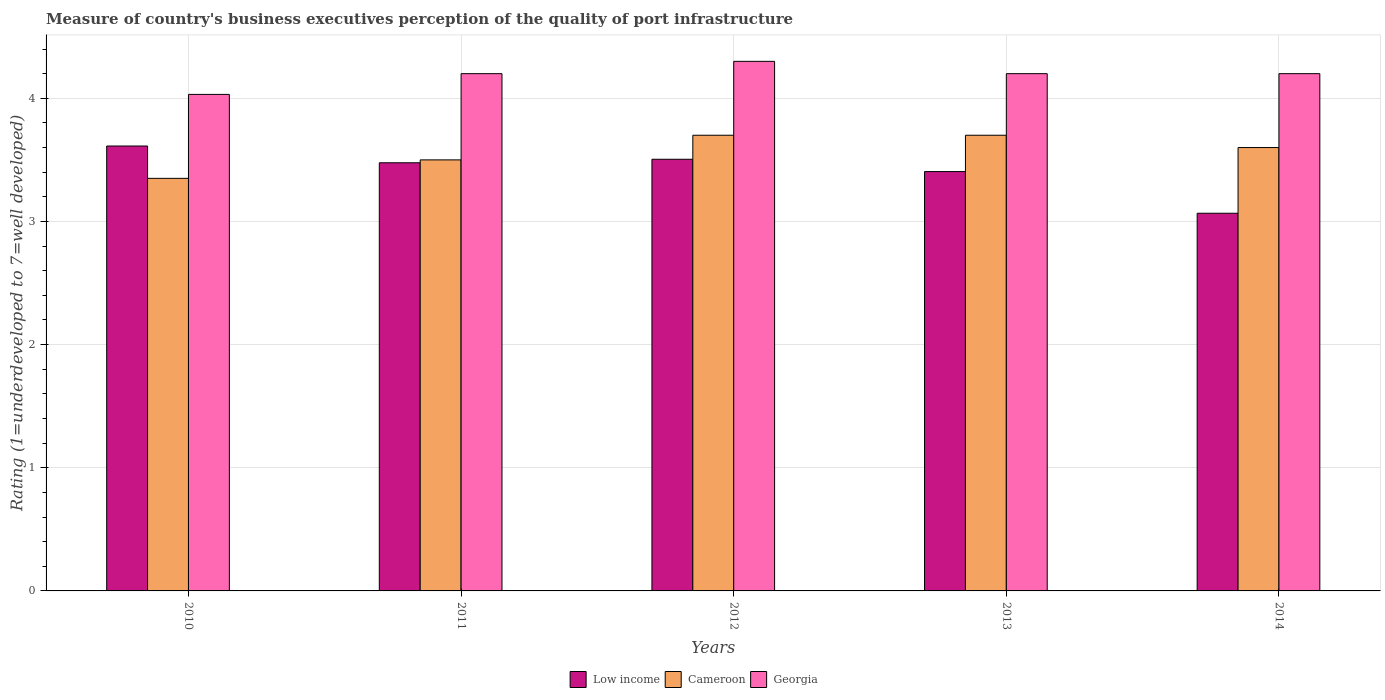Are the number of bars per tick equal to the number of legend labels?
Offer a very short reply. Yes. Are the number of bars on each tick of the X-axis equal?
Offer a very short reply. Yes. How many bars are there on the 2nd tick from the left?
Give a very brief answer. 3. In how many cases, is the number of bars for a given year not equal to the number of legend labels?
Your answer should be compact. 0. Across all years, what is the maximum ratings of the quality of port infrastructure in Low income?
Ensure brevity in your answer.  3.61. Across all years, what is the minimum ratings of the quality of port infrastructure in Cameroon?
Provide a short and direct response. 3.35. What is the total ratings of the quality of port infrastructure in Cameroon in the graph?
Give a very brief answer. 17.85. What is the difference between the ratings of the quality of port infrastructure in Cameroon in 2010 and that in 2013?
Ensure brevity in your answer.  -0.35. What is the difference between the ratings of the quality of port infrastructure in Georgia in 2014 and the ratings of the quality of port infrastructure in Low income in 2012?
Your answer should be compact. 0.7. What is the average ratings of the quality of port infrastructure in Georgia per year?
Give a very brief answer. 4.19. In the year 2014, what is the difference between the ratings of the quality of port infrastructure in Low income and ratings of the quality of port infrastructure in Cameroon?
Your answer should be compact. -0.53. In how many years, is the ratings of the quality of port infrastructure in Low income greater than 4.2?
Ensure brevity in your answer.  0. Is the difference between the ratings of the quality of port infrastructure in Low income in 2010 and 2013 greater than the difference between the ratings of the quality of port infrastructure in Cameroon in 2010 and 2013?
Give a very brief answer. Yes. What is the difference between the highest and the second highest ratings of the quality of port infrastructure in Low income?
Provide a short and direct response. 0.11. What is the difference between the highest and the lowest ratings of the quality of port infrastructure in Low income?
Provide a succinct answer. 0.55. Is the sum of the ratings of the quality of port infrastructure in Georgia in 2011 and 2014 greater than the maximum ratings of the quality of port infrastructure in Cameroon across all years?
Offer a very short reply. Yes. What does the 2nd bar from the left in 2011 represents?
Your answer should be compact. Cameroon. What does the 2nd bar from the right in 2013 represents?
Give a very brief answer. Cameroon. How many years are there in the graph?
Keep it short and to the point. 5. What is the difference between two consecutive major ticks on the Y-axis?
Provide a succinct answer. 1. Where does the legend appear in the graph?
Your answer should be compact. Bottom center. How many legend labels are there?
Keep it short and to the point. 3. How are the legend labels stacked?
Keep it short and to the point. Horizontal. What is the title of the graph?
Your response must be concise. Measure of country's business executives perception of the quality of port infrastructure. What is the label or title of the Y-axis?
Provide a short and direct response. Rating (1=underdeveloped to 7=well developed). What is the Rating (1=underdeveloped to 7=well developed) of Low income in 2010?
Offer a very short reply. 3.61. What is the Rating (1=underdeveloped to 7=well developed) in Cameroon in 2010?
Give a very brief answer. 3.35. What is the Rating (1=underdeveloped to 7=well developed) of Georgia in 2010?
Keep it short and to the point. 4.03. What is the Rating (1=underdeveloped to 7=well developed) in Low income in 2011?
Make the answer very short. 3.48. What is the Rating (1=underdeveloped to 7=well developed) in Cameroon in 2011?
Offer a terse response. 3.5. What is the Rating (1=underdeveloped to 7=well developed) of Low income in 2012?
Your answer should be very brief. 3.5. What is the Rating (1=underdeveloped to 7=well developed) in Low income in 2013?
Your response must be concise. 3.4. What is the Rating (1=underdeveloped to 7=well developed) of Cameroon in 2013?
Ensure brevity in your answer.  3.7. What is the Rating (1=underdeveloped to 7=well developed) of Georgia in 2013?
Ensure brevity in your answer.  4.2. What is the Rating (1=underdeveloped to 7=well developed) in Low income in 2014?
Your answer should be compact. 3.07. Across all years, what is the maximum Rating (1=underdeveloped to 7=well developed) in Low income?
Your response must be concise. 3.61. Across all years, what is the maximum Rating (1=underdeveloped to 7=well developed) in Georgia?
Provide a succinct answer. 4.3. Across all years, what is the minimum Rating (1=underdeveloped to 7=well developed) in Low income?
Keep it short and to the point. 3.07. Across all years, what is the minimum Rating (1=underdeveloped to 7=well developed) in Cameroon?
Provide a short and direct response. 3.35. Across all years, what is the minimum Rating (1=underdeveloped to 7=well developed) in Georgia?
Your response must be concise. 4.03. What is the total Rating (1=underdeveloped to 7=well developed) in Low income in the graph?
Give a very brief answer. 17.07. What is the total Rating (1=underdeveloped to 7=well developed) in Cameroon in the graph?
Your answer should be very brief. 17.85. What is the total Rating (1=underdeveloped to 7=well developed) of Georgia in the graph?
Your answer should be very brief. 20.93. What is the difference between the Rating (1=underdeveloped to 7=well developed) of Low income in 2010 and that in 2011?
Your answer should be compact. 0.14. What is the difference between the Rating (1=underdeveloped to 7=well developed) of Cameroon in 2010 and that in 2011?
Ensure brevity in your answer.  -0.15. What is the difference between the Rating (1=underdeveloped to 7=well developed) of Georgia in 2010 and that in 2011?
Your answer should be very brief. -0.17. What is the difference between the Rating (1=underdeveloped to 7=well developed) of Low income in 2010 and that in 2012?
Make the answer very short. 0.11. What is the difference between the Rating (1=underdeveloped to 7=well developed) of Cameroon in 2010 and that in 2012?
Your answer should be very brief. -0.35. What is the difference between the Rating (1=underdeveloped to 7=well developed) in Georgia in 2010 and that in 2012?
Your answer should be very brief. -0.27. What is the difference between the Rating (1=underdeveloped to 7=well developed) in Low income in 2010 and that in 2013?
Provide a succinct answer. 0.21. What is the difference between the Rating (1=underdeveloped to 7=well developed) in Cameroon in 2010 and that in 2013?
Your response must be concise. -0.35. What is the difference between the Rating (1=underdeveloped to 7=well developed) in Georgia in 2010 and that in 2013?
Keep it short and to the point. -0.17. What is the difference between the Rating (1=underdeveloped to 7=well developed) of Low income in 2010 and that in 2014?
Ensure brevity in your answer.  0.55. What is the difference between the Rating (1=underdeveloped to 7=well developed) of Cameroon in 2010 and that in 2014?
Your answer should be compact. -0.25. What is the difference between the Rating (1=underdeveloped to 7=well developed) in Georgia in 2010 and that in 2014?
Ensure brevity in your answer.  -0.17. What is the difference between the Rating (1=underdeveloped to 7=well developed) of Low income in 2011 and that in 2012?
Keep it short and to the point. -0.03. What is the difference between the Rating (1=underdeveloped to 7=well developed) in Cameroon in 2011 and that in 2012?
Your answer should be compact. -0.2. What is the difference between the Rating (1=underdeveloped to 7=well developed) in Georgia in 2011 and that in 2012?
Provide a succinct answer. -0.1. What is the difference between the Rating (1=underdeveloped to 7=well developed) in Low income in 2011 and that in 2013?
Your answer should be compact. 0.07. What is the difference between the Rating (1=underdeveloped to 7=well developed) in Georgia in 2011 and that in 2013?
Keep it short and to the point. 0. What is the difference between the Rating (1=underdeveloped to 7=well developed) of Low income in 2011 and that in 2014?
Your answer should be very brief. 0.41. What is the difference between the Rating (1=underdeveloped to 7=well developed) of Georgia in 2011 and that in 2014?
Your response must be concise. 0. What is the difference between the Rating (1=underdeveloped to 7=well developed) of Low income in 2012 and that in 2013?
Your answer should be very brief. 0.1. What is the difference between the Rating (1=underdeveloped to 7=well developed) of Cameroon in 2012 and that in 2013?
Your answer should be very brief. 0. What is the difference between the Rating (1=underdeveloped to 7=well developed) in Georgia in 2012 and that in 2013?
Offer a terse response. 0.1. What is the difference between the Rating (1=underdeveloped to 7=well developed) in Low income in 2012 and that in 2014?
Make the answer very short. 0.44. What is the difference between the Rating (1=underdeveloped to 7=well developed) of Georgia in 2012 and that in 2014?
Keep it short and to the point. 0.1. What is the difference between the Rating (1=underdeveloped to 7=well developed) in Low income in 2013 and that in 2014?
Ensure brevity in your answer.  0.34. What is the difference between the Rating (1=underdeveloped to 7=well developed) in Cameroon in 2013 and that in 2014?
Your response must be concise. 0.1. What is the difference between the Rating (1=underdeveloped to 7=well developed) of Low income in 2010 and the Rating (1=underdeveloped to 7=well developed) of Cameroon in 2011?
Offer a terse response. 0.11. What is the difference between the Rating (1=underdeveloped to 7=well developed) of Low income in 2010 and the Rating (1=underdeveloped to 7=well developed) of Georgia in 2011?
Keep it short and to the point. -0.59. What is the difference between the Rating (1=underdeveloped to 7=well developed) of Cameroon in 2010 and the Rating (1=underdeveloped to 7=well developed) of Georgia in 2011?
Your answer should be compact. -0.85. What is the difference between the Rating (1=underdeveloped to 7=well developed) in Low income in 2010 and the Rating (1=underdeveloped to 7=well developed) in Cameroon in 2012?
Offer a terse response. -0.09. What is the difference between the Rating (1=underdeveloped to 7=well developed) in Low income in 2010 and the Rating (1=underdeveloped to 7=well developed) in Georgia in 2012?
Your response must be concise. -0.69. What is the difference between the Rating (1=underdeveloped to 7=well developed) of Cameroon in 2010 and the Rating (1=underdeveloped to 7=well developed) of Georgia in 2012?
Make the answer very short. -0.95. What is the difference between the Rating (1=underdeveloped to 7=well developed) in Low income in 2010 and the Rating (1=underdeveloped to 7=well developed) in Cameroon in 2013?
Give a very brief answer. -0.09. What is the difference between the Rating (1=underdeveloped to 7=well developed) in Low income in 2010 and the Rating (1=underdeveloped to 7=well developed) in Georgia in 2013?
Offer a terse response. -0.59. What is the difference between the Rating (1=underdeveloped to 7=well developed) in Cameroon in 2010 and the Rating (1=underdeveloped to 7=well developed) in Georgia in 2013?
Your response must be concise. -0.85. What is the difference between the Rating (1=underdeveloped to 7=well developed) of Low income in 2010 and the Rating (1=underdeveloped to 7=well developed) of Cameroon in 2014?
Provide a short and direct response. 0.01. What is the difference between the Rating (1=underdeveloped to 7=well developed) of Low income in 2010 and the Rating (1=underdeveloped to 7=well developed) of Georgia in 2014?
Your answer should be compact. -0.59. What is the difference between the Rating (1=underdeveloped to 7=well developed) of Cameroon in 2010 and the Rating (1=underdeveloped to 7=well developed) of Georgia in 2014?
Your answer should be very brief. -0.85. What is the difference between the Rating (1=underdeveloped to 7=well developed) of Low income in 2011 and the Rating (1=underdeveloped to 7=well developed) of Cameroon in 2012?
Your response must be concise. -0.22. What is the difference between the Rating (1=underdeveloped to 7=well developed) of Low income in 2011 and the Rating (1=underdeveloped to 7=well developed) of Georgia in 2012?
Provide a succinct answer. -0.82. What is the difference between the Rating (1=underdeveloped to 7=well developed) in Cameroon in 2011 and the Rating (1=underdeveloped to 7=well developed) in Georgia in 2012?
Give a very brief answer. -0.8. What is the difference between the Rating (1=underdeveloped to 7=well developed) in Low income in 2011 and the Rating (1=underdeveloped to 7=well developed) in Cameroon in 2013?
Offer a terse response. -0.22. What is the difference between the Rating (1=underdeveloped to 7=well developed) in Low income in 2011 and the Rating (1=underdeveloped to 7=well developed) in Georgia in 2013?
Ensure brevity in your answer.  -0.72. What is the difference between the Rating (1=underdeveloped to 7=well developed) in Cameroon in 2011 and the Rating (1=underdeveloped to 7=well developed) in Georgia in 2013?
Keep it short and to the point. -0.7. What is the difference between the Rating (1=underdeveloped to 7=well developed) of Low income in 2011 and the Rating (1=underdeveloped to 7=well developed) of Cameroon in 2014?
Offer a very short reply. -0.12. What is the difference between the Rating (1=underdeveloped to 7=well developed) of Low income in 2011 and the Rating (1=underdeveloped to 7=well developed) of Georgia in 2014?
Give a very brief answer. -0.72. What is the difference between the Rating (1=underdeveloped to 7=well developed) of Cameroon in 2011 and the Rating (1=underdeveloped to 7=well developed) of Georgia in 2014?
Offer a very short reply. -0.7. What is the difference between the Rating (1=underdeveloped to 7=well developed) in Low income in 2012 and the Rating (1=underdeveloped to 7=well developed) in Cameroon in 2013?
Offer a very short reply. -0.2. What is the difference between the Rating (1=underdeveloped to 7=well developed) of Low income in 2012 and the Rating (1=underdeveloped to 7=well developed) of Georgia in 2013?
Make the answer very short. -0.69. What is the difference between the Rating (1=underdeveloped to 7=well developed) in Cameroon in 2012 and the Rating (1=underdeveloped to 7=well developed) in Georgia in 2013?
Offer a terse response. -0.5. What is the difference between the Rating (1=underdeveloped to 7=well developed) of Low income in 2012 and the Rating (1=underdeveloped to 7=well developed) of Cameroon in 2014?
Your response must be concise. -0.1. What is the difference between the Rating (1=underdeveloped to 7=well developed) in Low income in 2012 and the Rating (1=underdeveloped to 7=well developed) in Georgia in 2014?
Your response must be concise. -0.69. What is the difference between the Rating (1=underdeveloped to 7=well developed) in Low income in 2013 and the Rating (1=underdeveloped to 7=well developed) in Cameroon in 2014?
Your answer should be compact. -0.2. What is the difference between the Rating (1=underdeveloped to 7=well developed) in Low income in 2013 and the Rating (1=underdeveloped to 7=well developed) in Georgia in 2014?
Keep it short and to the point. -0.8. What is the average Rating (1=underdeveloped to 7=well developed) of Low income per year?
Your answer should be compact. 3.41. What is the average Rating (1=underdeveloped to 7=well developed) of Cameroon per year?
Your answer should be compact. 3.57. What is the average Rating (1=underdeveloped to 7=well developed) of Georgia per year?
Offer a very short reply. 4.19. In the year 2010, what is the difference between the Rating (1=underdeveloped to 7=well developed) of Low income and Rating (1=underdeveloped to 7=well developed) of Cameroon?
Provide a succinct answer. 0.26. In the year 2010, what is the difference between the Rating (1=underdeveloped to 7=well developed) of Low income and Rating (1=underdeveloped to 7=well developed) of Georgia?
Give a very brief answer. -0.42. In the year 2010, what is the difference between the Rating (1=underdeveloped to 7=well developed) in Cameroon and Rating (1=underdeveloped to 7=well developed) in Georgia?
Provide a succinct answer. -0.68. In the year 2011, what is the difference between the Rating (1=underdeveloped to 7=well developed) of Low income and Rating (1=underdeveloped to 7=well developed) of Cameroon?
Ensure brevity in your answer.  -0.02. In the year 2011, what is the difference between the Rating (1=underdeveloped to 7=well developed) of Low income and Rating (1=underdeveloped to 7=well developed) of Georgia?
Provide a short and direct response. -0.72. In the year 2011, what is the difference between the Rating (1=underdeveloped to 7=well developed) in Cameroon and Rating (1=underdeveloped to 7=well developed) in Georgia?
Make the answer very short. -0.7. In the year 2012, what is the difference between the Rating (1=underdeveloped to 7=well developed) in Low income and Rating (1=underdeveloped to 7=well developed) in Cameroon?
Ensure brevity in your answer.  -0.2. In the year 2012, what is the difference between the Rating (1=underdeveloped to 7=well developed) of Low income and Rating (1=underdeveloped to 7=well developed) of Georgia?
Give a very brief answer. -0.8. In the year 2012, what is the difference between the Rating (1=underdeveloped to 7=well developed) of Cameroon and Rating (1=underdeveloped to 7=well developed) of Georgia?
Offer a terse response. -0.6. In the year 2013, what is the difference between the Rating (1=underdeveloped to 7=well developed) of Low income and Rating (1=underdeveloped to 7=well developed) of Cameroon?
Your answer should be very brief. -0.29. In the year 2013, what is the difference between the Rating (1=underdeveloped to 7=well developed) in Low income and Rating (1=underdeveloped to 7=well developed) in Georgia?
Your response must be concise. -0.8. In the year 2014, what is the difference between the Rating (1=underdeveloped to 7=well developed) in Low income and Rating (1=underdeveloped to 7=well developed) in Cameroon?
Offer a very short reply. -0.53. In the year 2014, what is the difference between the Rating (1=underdeveloped to 7=well developed) of Low income and Rating (1=underdeveloped to 7=well developed) of Georgia?
Your answer should be compact. -1.13. In the year 2014, what is the difference between the Rating (1=underdeveloped to 7=well developed) in Cameroon and Rating (1=underdeveloped to 7=well developed) in Georgia?
Provide a short and direct response. -0.6. What is the ratio of the Rating (1=underdeveloped to 7=well developed) in Low income in 2010 to that in 2011?
Your answer should be very brief. 1.04. What is the ratio of the Rating (1=underdeveloped to 7=well developed) of Cameroon in 2010 to that in 2011?
Offer a terse response. 0.96. What is the ratio of the Rating (1=underdeveloped to 7=well developed) of Georgia in 2010 to that in 2011?
Keep it short and to the point. 0.96. What is the ratio of the Rating (1=underdeveloped to 7=well developed) in Low income in 2010 to that in 2012?
Ensure brevity in your answer.  1.03. What is the ratio of the Rating (1=underdeveloped to 7=well developed) in Cameroon in 2010 to that in 2012?
Your answer should be compact. 0.91. What is the ratio of the Rating (1=underdeveloped to 7=well developed) of Georgia in 2010 to that in 2012?
Make the answer very short. 0.94. What is the ratio of the Rating (1=underdeveloped to 7=well developed) in Low income in 2010 to that in 2013?
Keep it short and to the point. 1.06. What is the ratio of the Rating (1=underdeveloped to 7=well developed) in Cameroon in 2010 to that in 2013?
Ensure brevity in your answer.  0.91. What is the ratio of the Rating (1=underdeveloped to 7=well developed) in Georgia in 2010 to that in 2013?
Your answer should be very brief. 0.96. What is the ratio of the Rating (1=underdeveloped to 7=well developed) of Low income in 2010 to that in 2014?
Your answer should be very brief. 1.18. What is the ratio of the Rating (1=underdeveloped to 7=well developed) in Cameroon in 2010 to that in 2014?
Keep it short and to the point. 0.93. What is the ratio of the Rating (1=underdeveloped to 7=well developed) in Georgia in 2010 to that in 2014?
Keep it short and to the point. 0.96. What is the ratio of the Rating (1=underdeveloped to 7=well developed) of Cameroon in 2011 to that in 2012?
Offer a very short reply. 0.95. What is the ratio of the Rating (1=underdeveloped to 7=well developed) of Georgia in 2011 to that in 2012?
Offer a very short reply. 0.98. What is the ratio of the Rating (1=underdeveloped to 7=well developed) of Cameroon in 2011 to that in 2013?
Keep it short and to the point. 0.95. What is the ratio of the Rating (1=underdeveloped to 7=well developed) in Low income in 2011 to that in 2014?
Keep it short and to the point. 1.13. What is the ratio of the Rating (1=underdeveloped to 7=well developed) of Cameroon in 2011 to that in 2014?
Offer a very short reply. 0.97. What is the ratio of the Rating (1=underdeveloped to 7=well developed) of Georgia in 2011 to that in 2014?
Make the answer very short. 1. What is the ratio of the Rating (1=underdeveloped to 7=well developed) in Low income in 2012 to that in 2013?
Offer a terse response. 1.03. What is the ratio of the Rating (1=underdeveloped to 7=well developed) in Georgia in 2012 to that in 2013?
Offer a very short reply. 1.02. What is the ratio of the Rating (1=underdeveloped to 7=well developed) in Cameroon in 2012 to that in 2014?
Provide a short and direct response. 1.03. What is the ratio of the Rating (1=underdeveloped to 7=well developed) in Georgia in 2012 to that in 2014?
Make the answer very short. 1.02. What is the ratio of the Rating (1=underdeveloped to 7=well developed) in Low income in 2013 to that in 2014?
Ensure brevity in your answer.  1.11. What is the ratio of the Rating (1=underdeveloped to 7=well developed) of Cameroon in 2013 to that in 2014?
Give a very brief answer. 1.03. What is the difference between the highest and the second highest Rating (1=underdeveloped to 7=well developed) in Low income?
Your answer should be very brief. 0.11. What is the difference between the highest and the second highest Rating (1=underdeveloped to 7=well developed) of Georgia?
Ensure brevity in your answer.  0.1. What is the difference between the highest and the lowest Rating (1=underdeveloped to 7=well developed) of Low income?
Make the answer very short. 0.55. What is the difference between the highest and the lowest Rating (1=underdeveloped to 7=well developed) in Cameroon?
Your response must be concise. 0.35. What is the difference between the highest and the lowest Rating (1=underdeveloped to 7=well developed) of Georgia?
Your answer should be compact. 0.27. 